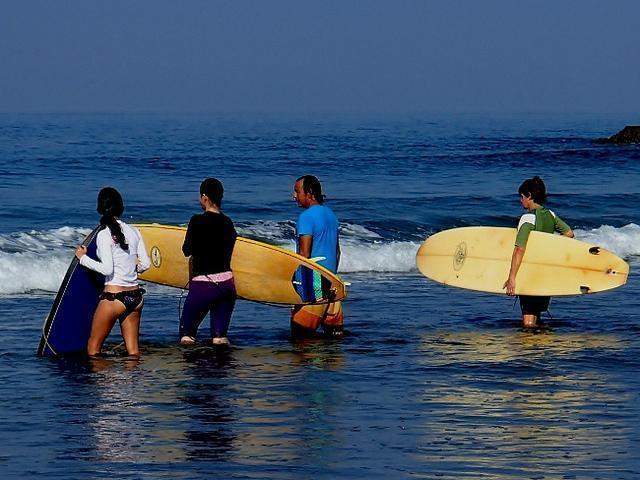What type of surfboard does the woman with the black pants have?
Select the accurate response from the four choices given to answer the question.
Options: Fish, gun, shortboard, hybrid. Gun. 